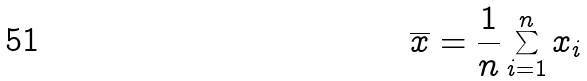Convert formula to latex. <formula><loc_0><loc_0><loc_500><loc_500>\overline { x } = \frac { 1 } { n } \sum _ { i = 1 } ^ { n } x _ { i }</formula> 